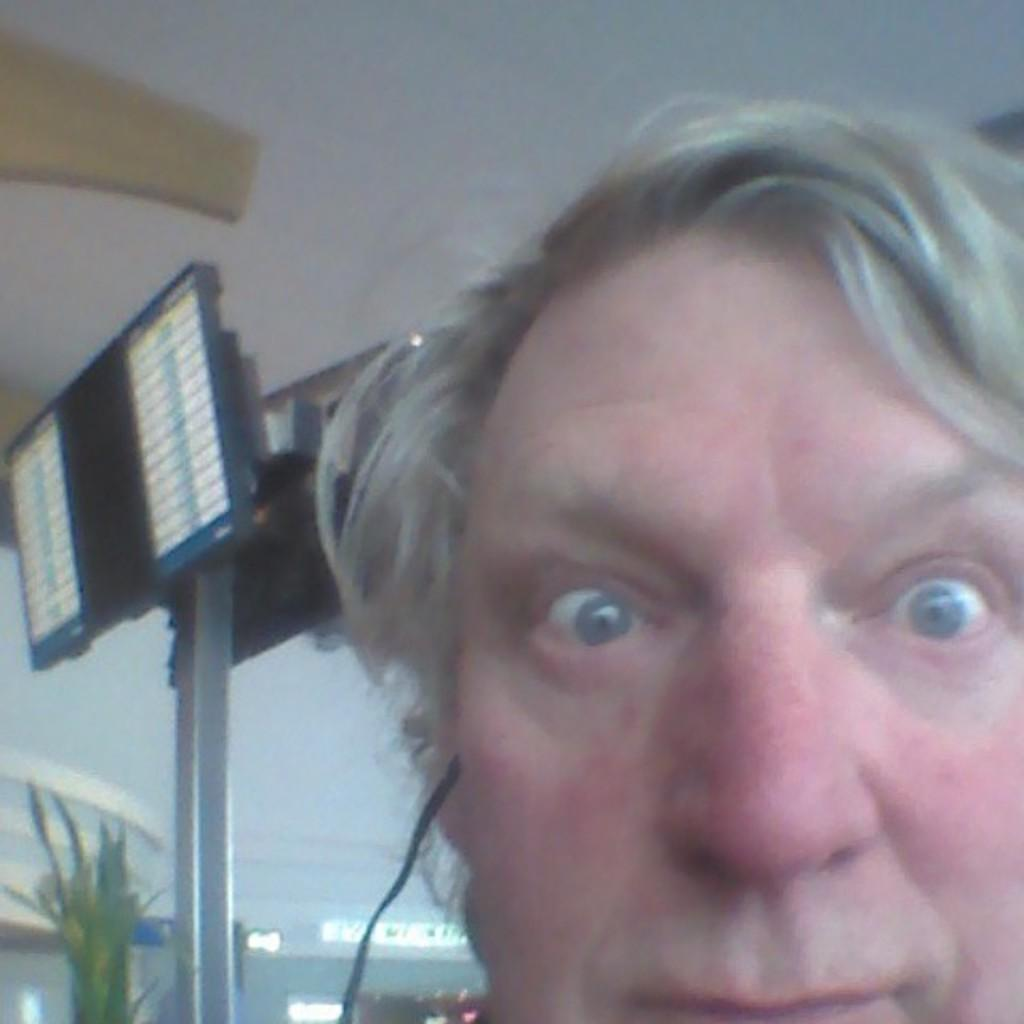Who is present in the image? There is a man in the image. What can be seen in the background of the image? There is a pole with lights in the background of the image. What type of tray is the man holding in the image? There is no tray present in the image. How many bulbs are visible on the pole in the image? The number of bulbs on the pole cannot be determined from the image. 